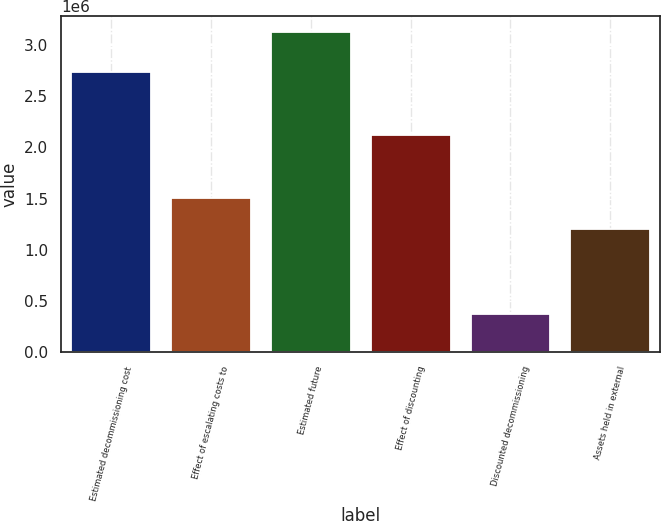Convert chart. <chart><loc_0><loc_0><loc_500><loc_500><bar_chart><fcel>Estimated decommissioning cost<fcel>Effect of escalating costs to<fcel>Estimated future<fcel>Effect of discounting<fcel>Discounted decommissioning<fcel>Assets held in external<nl><fcel>2.73371e+06<fcel>1.50729e+06<fcel>3.12683e+06<fcel>2.1205e+06<fcel>367387<fcel>1.20069e+06<nl></chart> 